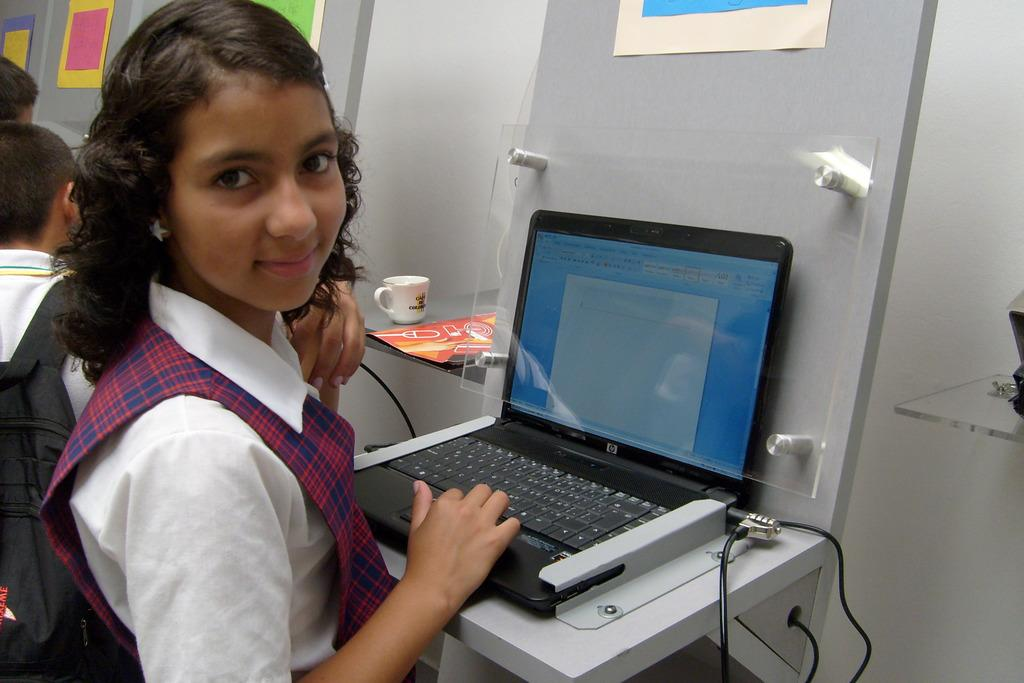Provide a one-sentence caption for the provided image. A young girl in a uniform sits in front of an HP laptop. 